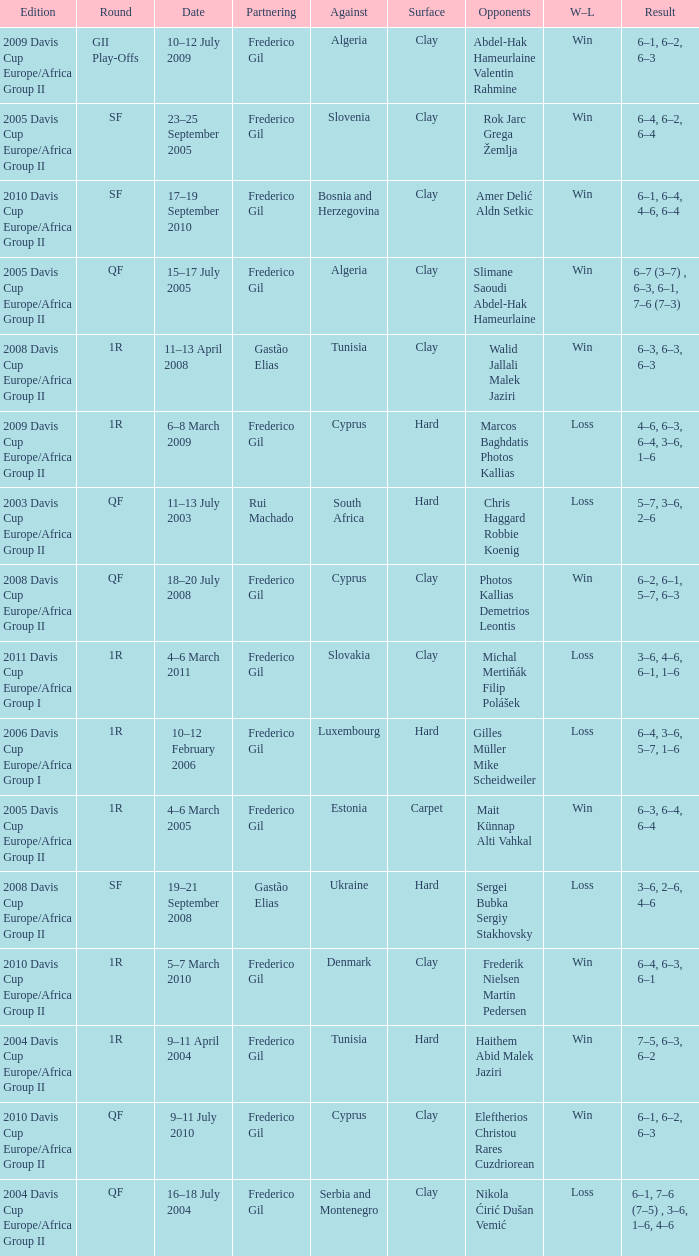How many rounds were there in the 2006 davis cup europe/africa group I? 1.0. 